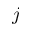<formula> <loc_0><loc_0><loc_500><loc_500>j</formula> 